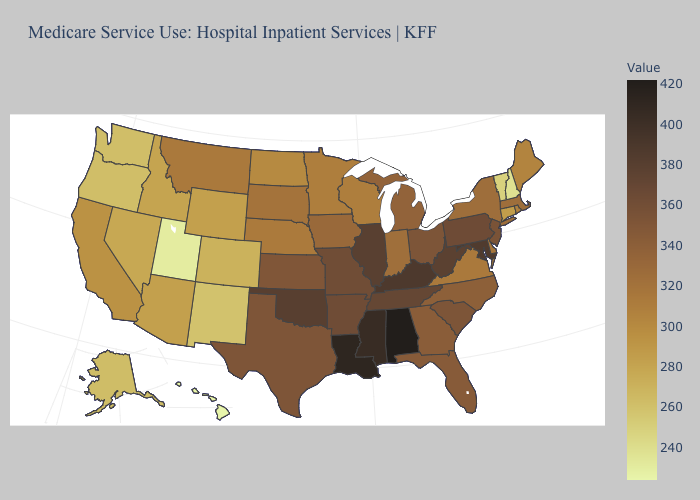Does Hawaii have the lowest value in the West?
Write a very short answer. Yes. Does Alabama have the highest value in the USA?
Short answer required. Yes. Among the states that border Vermont , which have the lowest value?
Be succinct. New Hampshire. Among the states that border Mississippi , does Alabama have the lowest value?
Keep it brief. No. Does Arkansas have the highest value in the USA?
Short answer required. No. Does Alabama have the highest value in the USA?
Short answer required. Yes. 